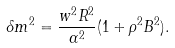<formula> <loc_0><loc_0><loc_500><loc_500>\delta m ^ { 2 } = \frac { w ^ { 2 } R ^ { 2 } } { \alpha ^ { 2 } } ( 1 + \rho ^ { 2 } B ^ { 2 } ) .</formula> 